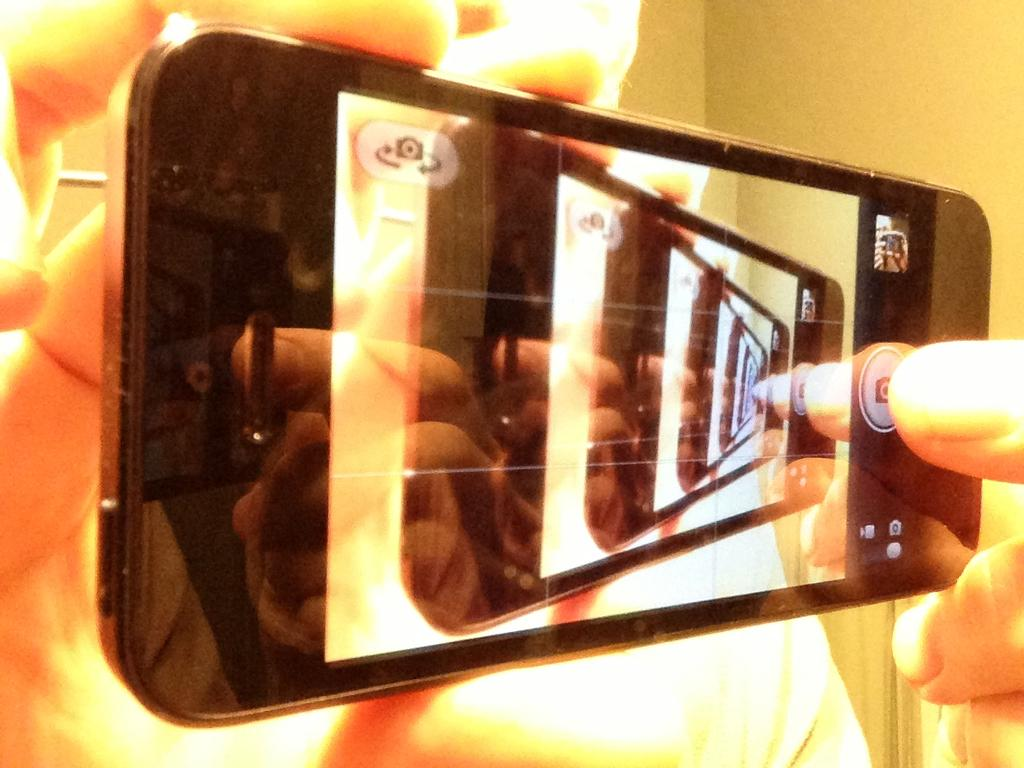What body part is visible in the image? The hands of a person are visible in the image. What are the hands holding? The hands are holding a mobile. What type of cabbage is being used to tell a story in the image? There is no cabbage or storytelling activity present in the image. 